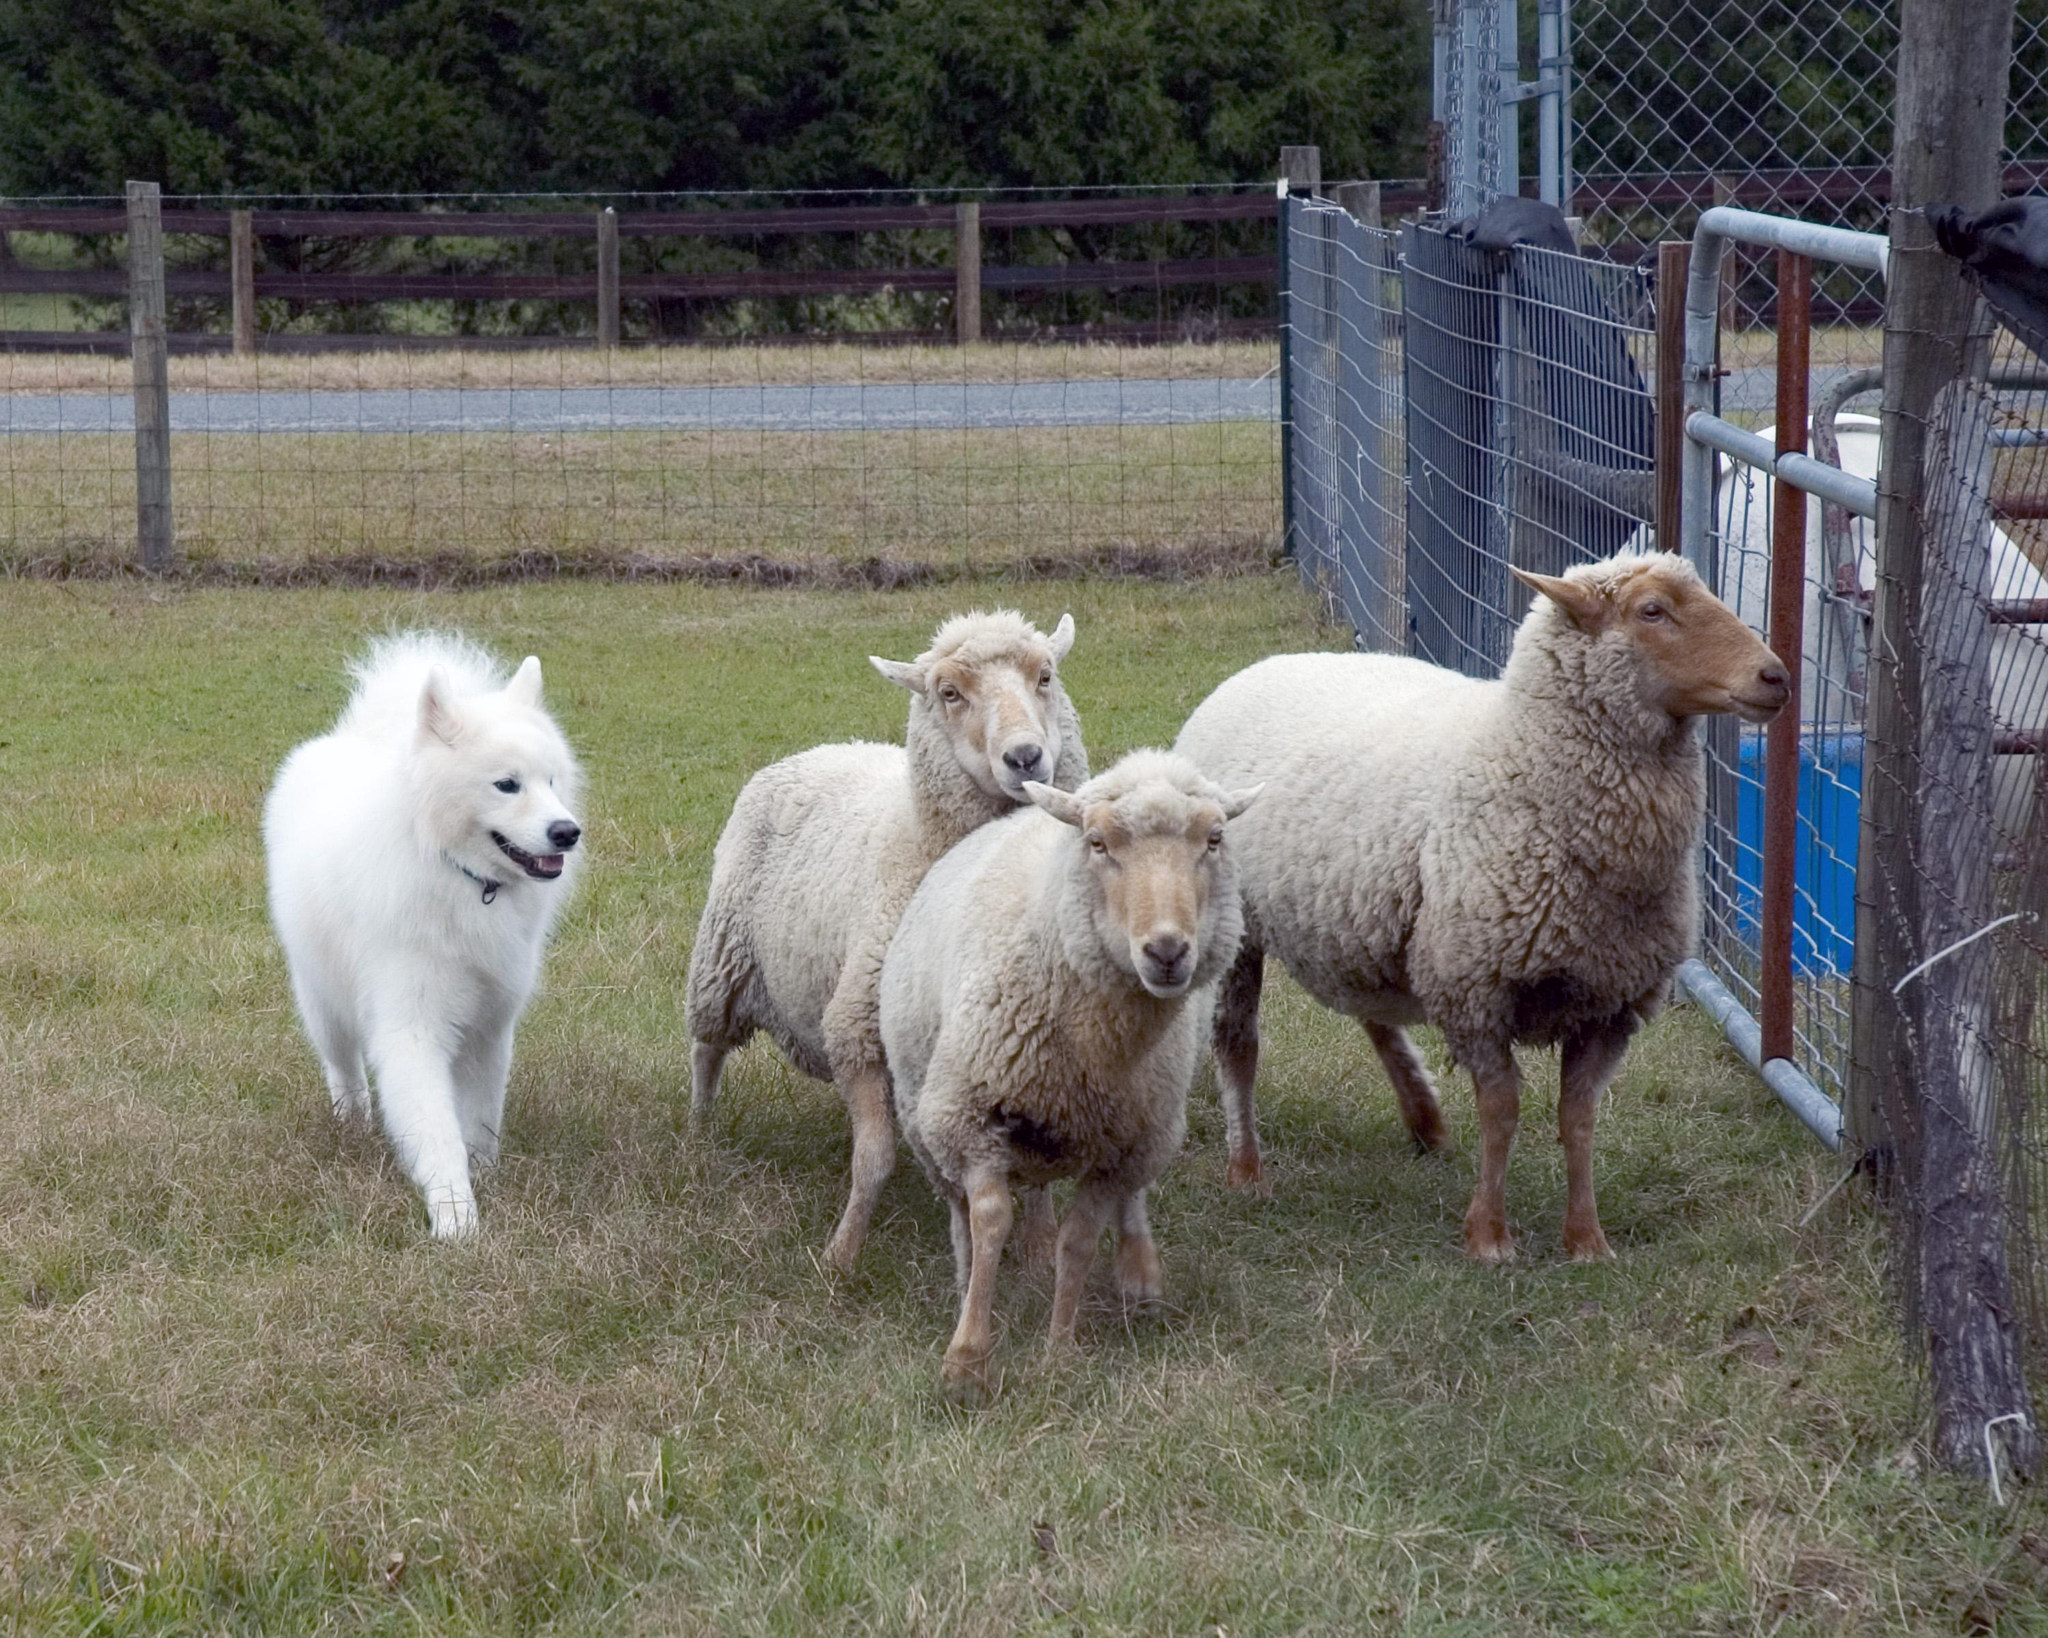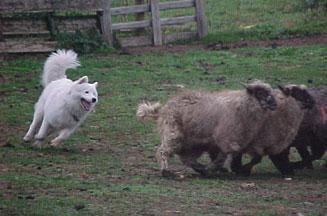The first image is the image on the left, the second image is the image on the right. For the images shown, is this caption "At least one image shows a woman holding a stick while working with sheep and dog." true? Answer yes or no. No. The first image is the image on the left, the second image is the image on the right. For the images displayed, is the sentence "A white dog is in an enclosure working with sheep." factually correct? Answer yes or no. Yes. 